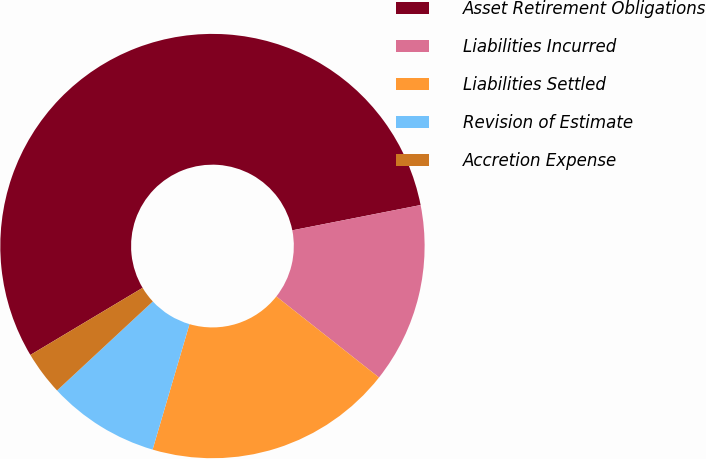Convert chart. <chart><loc_0><loc_0><loc_500><loc_500><pie_chart><fcel>Asset Retirement Obligations<fcel>Liabilities Incurred<fcel>Liabilities Settled<fcel>Revision of Estimate<fcel>Accretion Expense<nl><fcel>55.48%<fcel>13.73%<fcel>18.92%<fcel>8.53%<fcel>3.34%<nl></chart> 